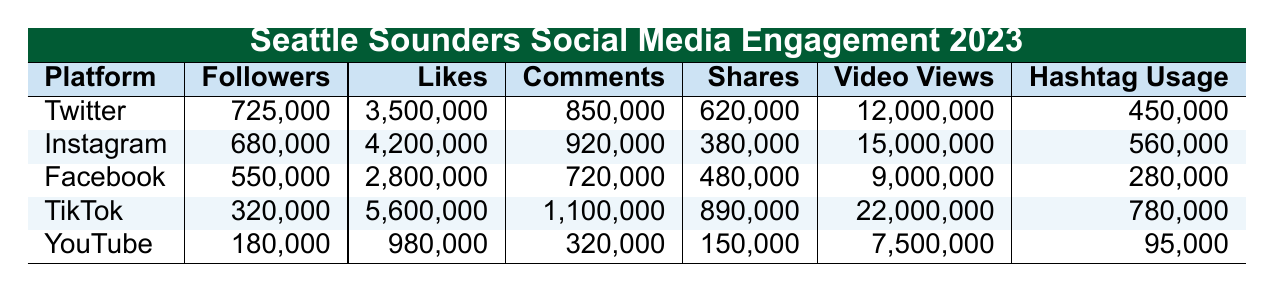What's the total number of followers across all platforms? To find the total number of followers, we add up the follower counts for each platform: 725,000 (Twitter) + 680,000 (Instagram) + 550,000 (Facebook) + 320,000 (TikTok) + 180,000 (YouTube) = 2,455,000
Answer: 2,455,000 Which platform has the highest number of likes? Looking at the likes for each platform, TikTok has 5,600,000, which is more than the other platforms: Twitter (3,500,000), Instagram (4,200,000), Facebook (2,800,000), and YouTube (980,000).
Answer: TikTok What is the average number of comments across all platforms? To calculate the average, first we sum the comments: 850,000 (Twitter) + 920,000 (Instagram) + 720,000 (Facebook) + 1,100,000 (TikTok) + 320,000 (YouTube) = 3,910,000. There are 5 platforms, so the average is 3,910,000 / 5 = 782,000.
Answer: 782,000 Is the video views count on TikTok greater than the total video views on the other platforms combined? TikTok has 22,000,000 video views. The total views for others are: Twitter (12,000,000) + Instagram (15,000,000) + Facebook (9,000,000) + YouTube (7,500,000) = 43,500,000. Since 22,000,000 is less than 43,500,000, the statement is false.
Answer: No What is the difference in followers between Twitter and Instagram? Twitter has 725,000 followers and Instagram has 680,000 followers. The difference is 725,000 - 680,000 = 45,000.
Answer: 45,000 Which platform has the least amount of shares, and how many shares does it have? The shares data shows YouTube has the lowest number with 150,000. Comparing all platforms: Twitter (620,000), Instagram (380,000), Facebook (480,000), TikTok (890,000), and YouTube (150,000), YouTube is the least.
Answer: YouTube, 150,000 What percentage of total likes comes from TikTok? TikTok has 5,600,000 likes. The total likes are: 3,500,000 (Twitter) + 4,200,000 (Instagram) + 2,800,000 (Facebook) + 5,600,000 (TikTok) + 980,000 (YouTube) = 17,080,000. The percentage is (5,600,000 / 17,080,000) * 100 ≈ 32.8%.
Answer: 32.8% Which fan interaction campaign could potentially lead to the highest engagement based on the social media platforms used? The "MarchToTheMatch hashtag challenge" can leverage multiple platforms with high engagement metrics—especially if it encourages fans to share on TikTok and Instagram, which have top engagement rates.
Answer: MarchToTheMatch hashtag challenge 